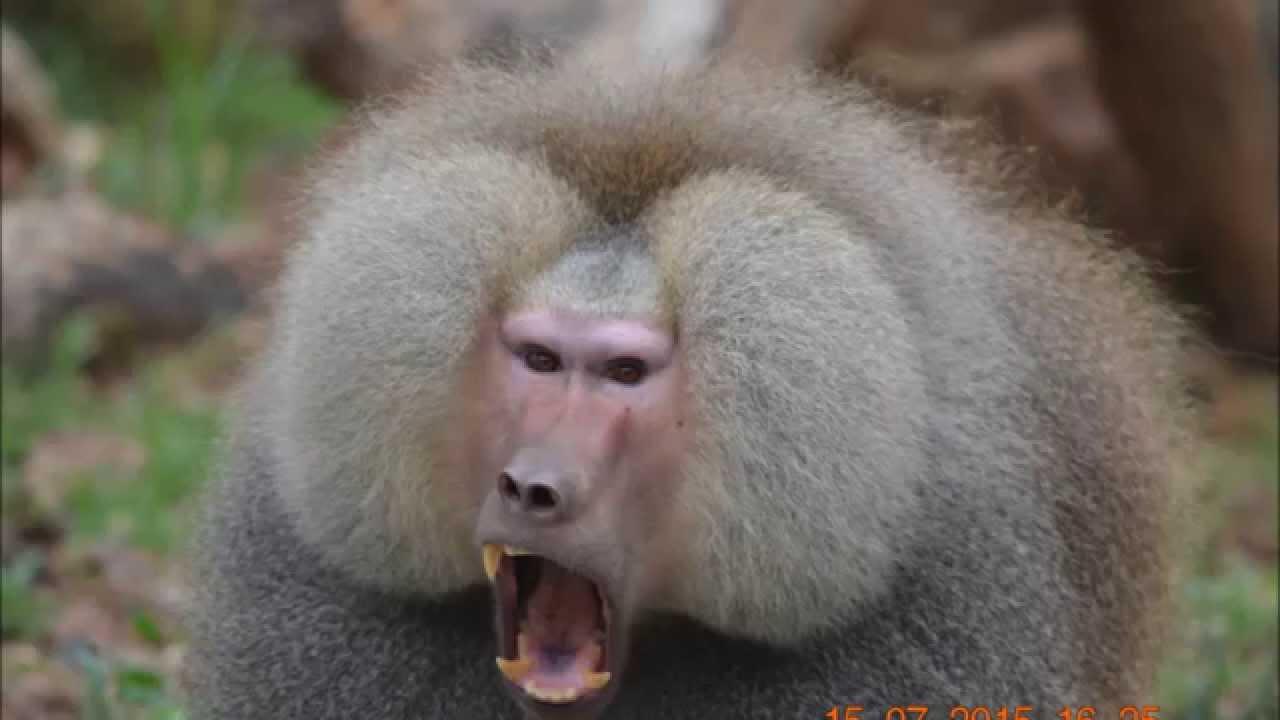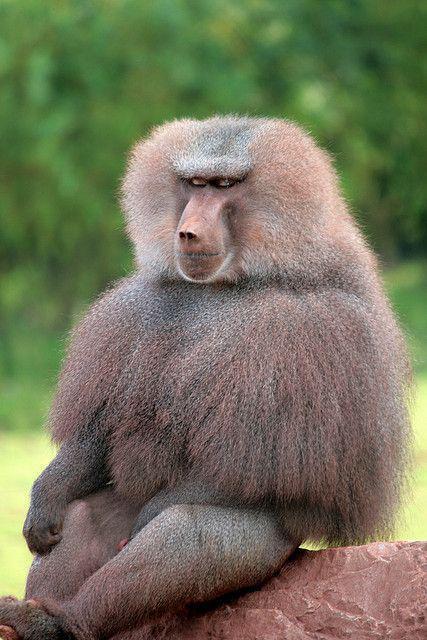The first image is the image on the left, the second image is the image on the right. Evaluate the accuracy of this statement regarding the images: "The left image is of a single animal with its mouth open.". Is it true? Answer yes or no. Yes. 